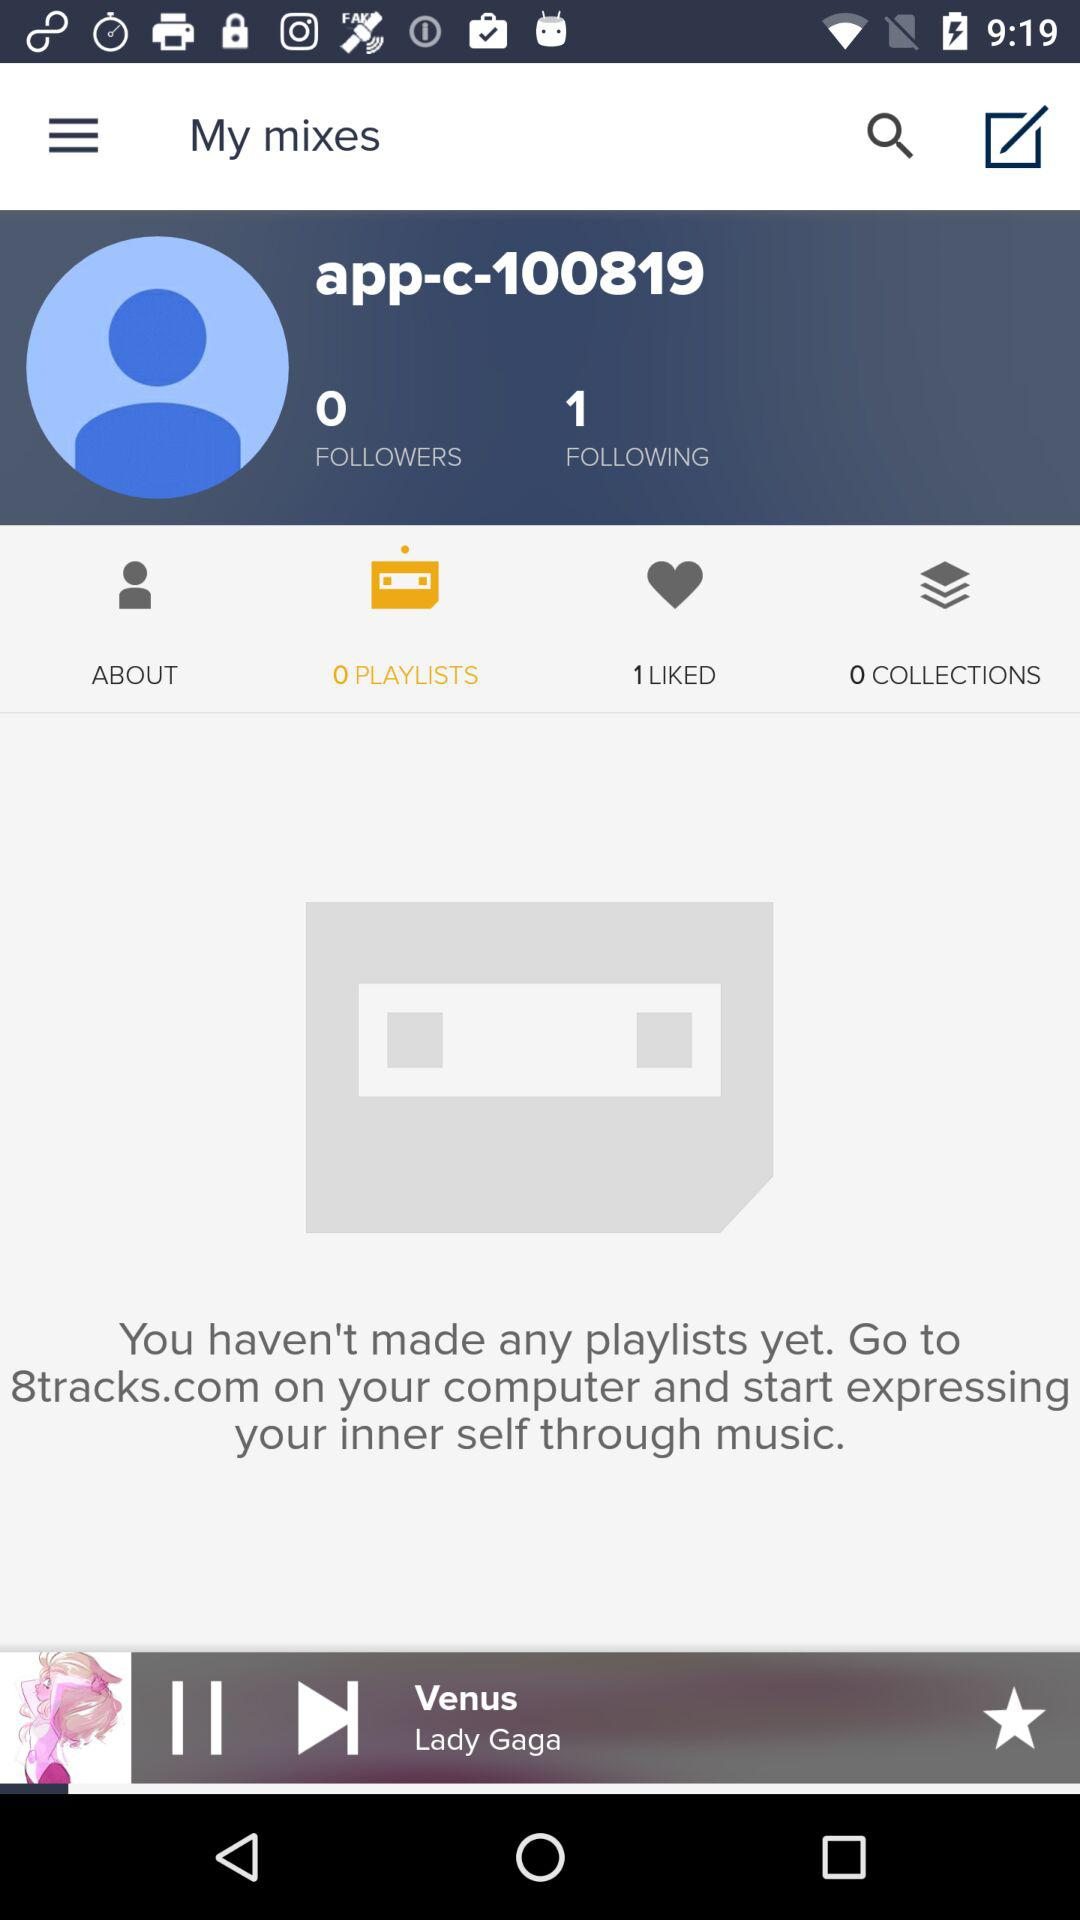How many people does the user follow? The user follows 1 person. 